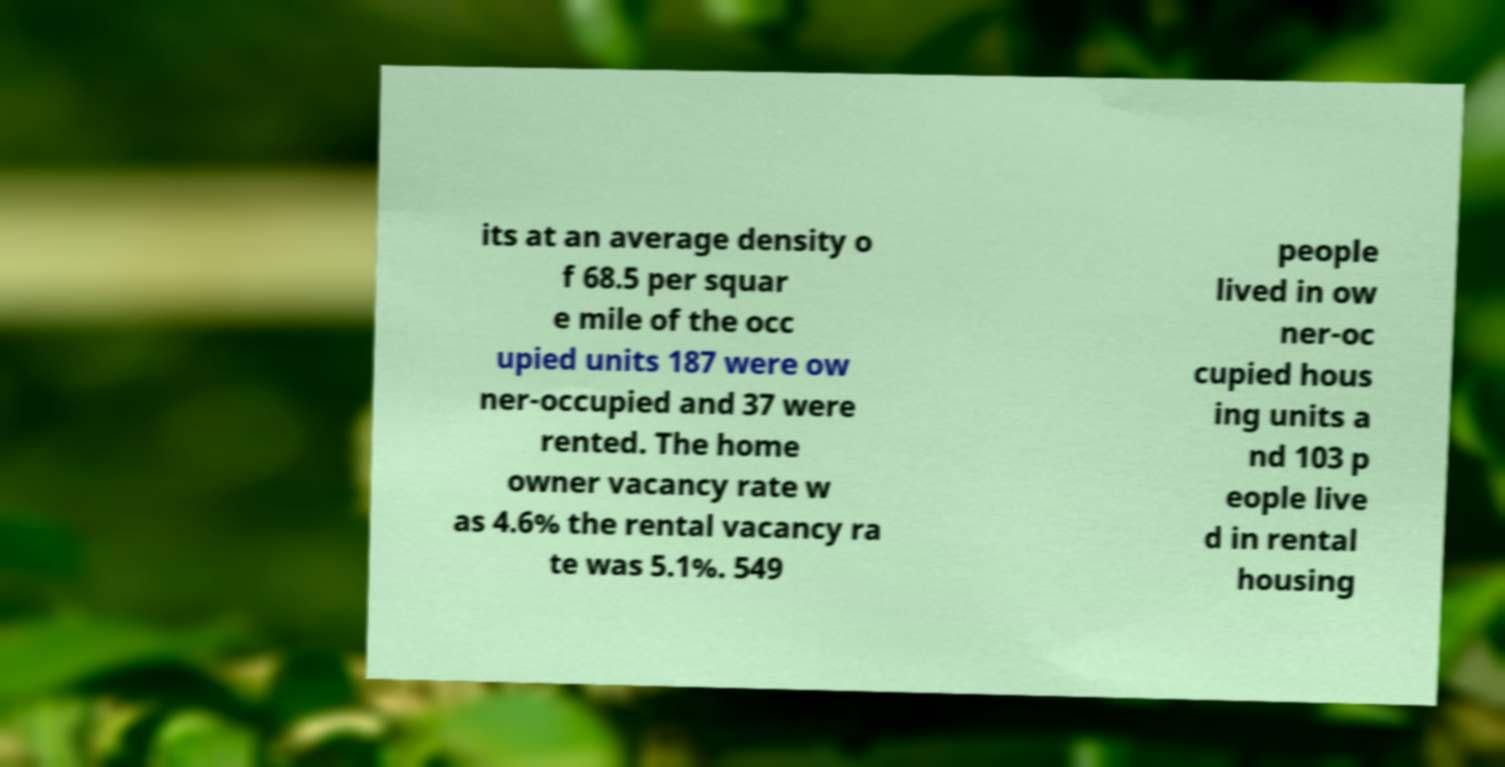What messages or text are displayed in this image? I need them in a readable, typed format. its at an average density o f 68.5 per squar e mile of the occ upied units 187 were ow ner-occupied and 37 were rented. The home owner vacancy rate w as 4.6% the rental vacancy ra te was 5.1%. 549 people lived in ow ner-oc cupied hous ing units a nd 103 p eople live d in rental housing 